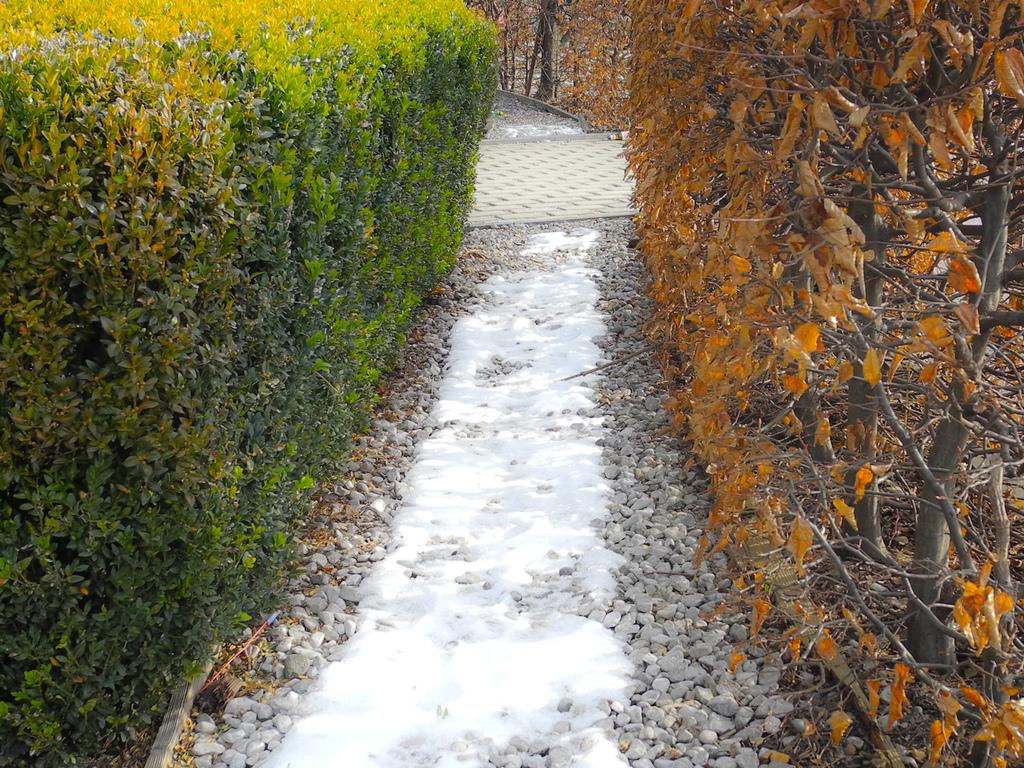What type of vegetation can be seen in the image? There are bushes and creepers in the image. What is the surface of the walking path made of in the image? The walking path in the image has stones on it. What type of bat can be seen hanging from the creepers in the image? There are no bats present in the image; it only features bushes, creepers, and a walking path with stones. 